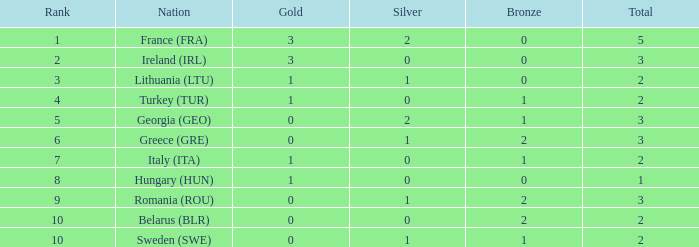What is the sum when gold is below 0 and silver is below 1? None. 